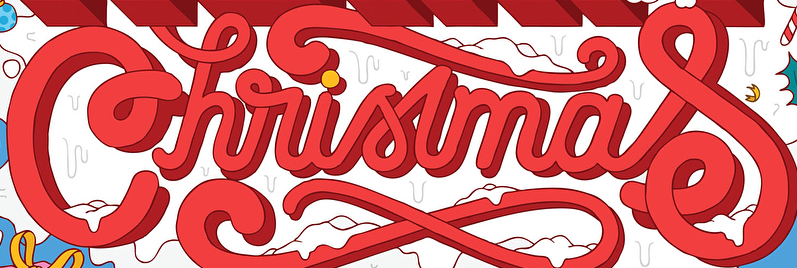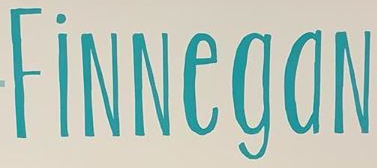What words can you see in these images in sequence, separated by a semicolon? Christmas; FiNNegaN 